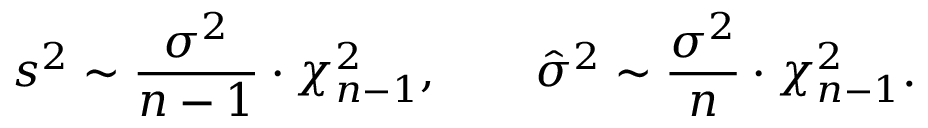<formula> <loc_0><loc_0><loc_500><loc_500>s ^ { 2 } \sim { \frac { \sigma ^ { 2 } } { n - 1 } } \cdot \chi _ { n - 1 } ^ { 2 } , \quad { \hat { \sigma } } ^ { 2 } \sim { \frac { \sigma ^ { 2 } } { n } } \cdot \chi _ { n - 1 } ^ { 2 } .</formula> 